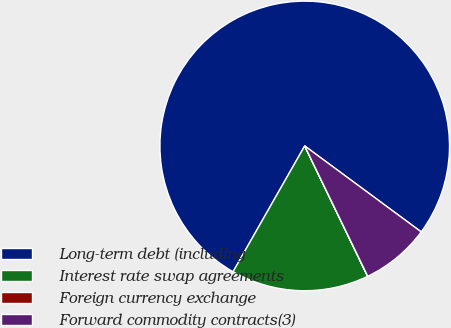Convert chart to OTSL. <chart><loc_0><loc_0><loc_500><loc_500><pie_chart><fcel>Long-term debt (including<fcel>Interest rate swap agreements<fcel>Foreign currency exchange<fcel>Forward commodity contracts(3)<nl><fcel>76.88%<fcel>15.39%<fcel>0.02%<fcel>7.71%<nl></chart> 